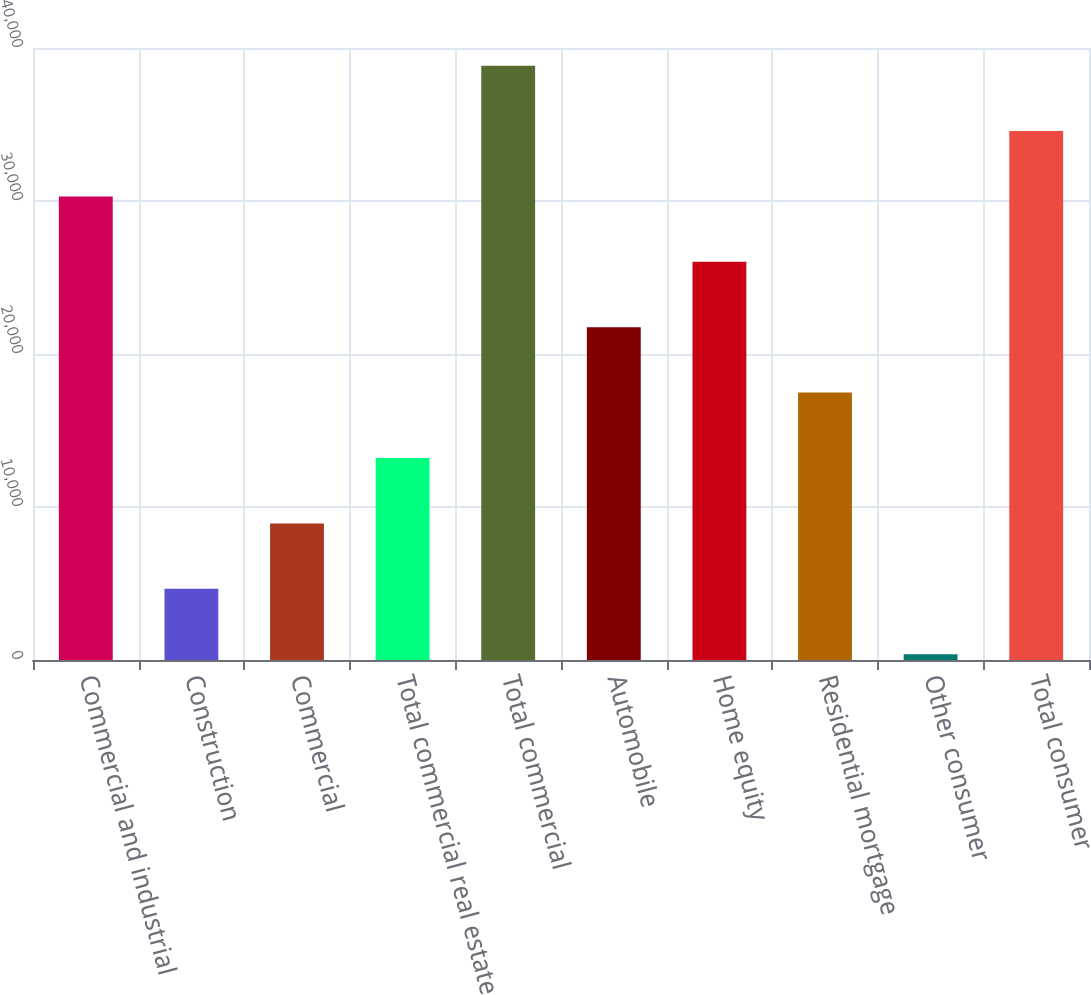<chart> <loc_0><loc_0><loc_500><loc_500><bar_chart><fcel>Commercial and industrial<fcel>Construction<fcel>Commercial<fcel>Total commercial real estate<fcel>Total commercial<fcel>Automobile<fcel>Home equity<fcel>Residential mortgage<fcel>Other consumer<fcel>Total consumer<nl><fcel>30298<fcel>4654<fcel>8928<fcel>13202<fcel>38846<fcel>21750<fcel>26024<fcel>17476<fcel>380<fcel>34572<nl></chart> 